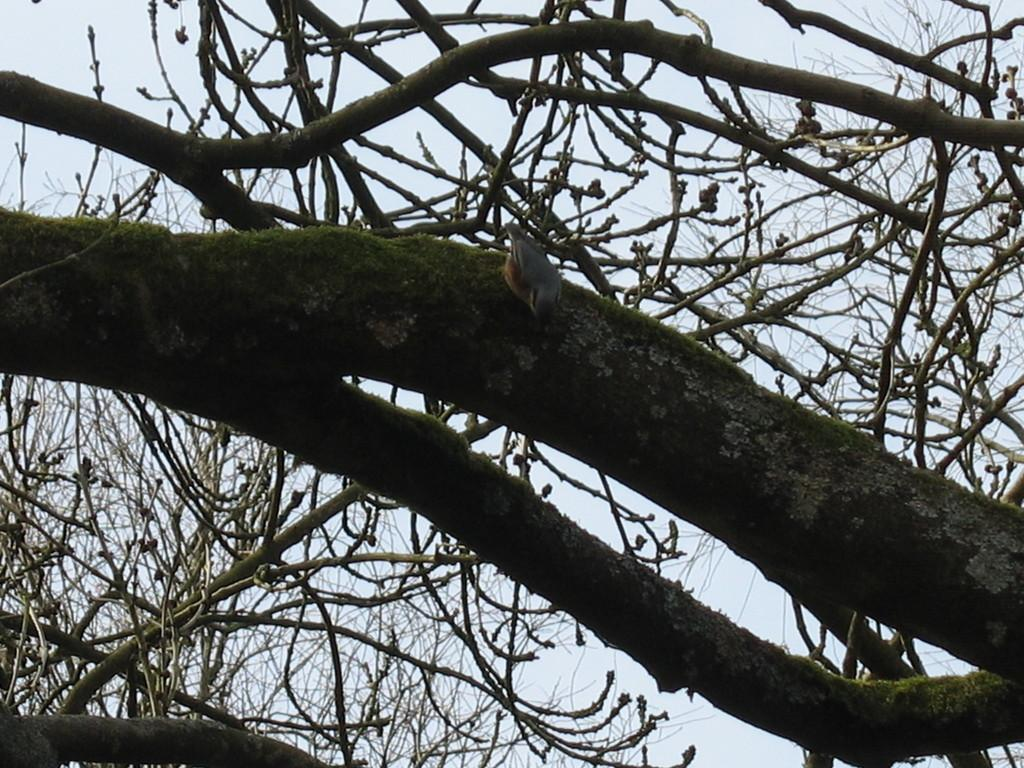What type of animal is in the image? There is a bird in the image. Where is the bird located? The bird is on a trunk. What can be seen in the background of the image? There are branches and the sky visible in the background of the image. What is the bird's wealth status in the image? The bird's wealth status cannot be determined from the image, as wealth is not a characteristic that can be observed in animals. 